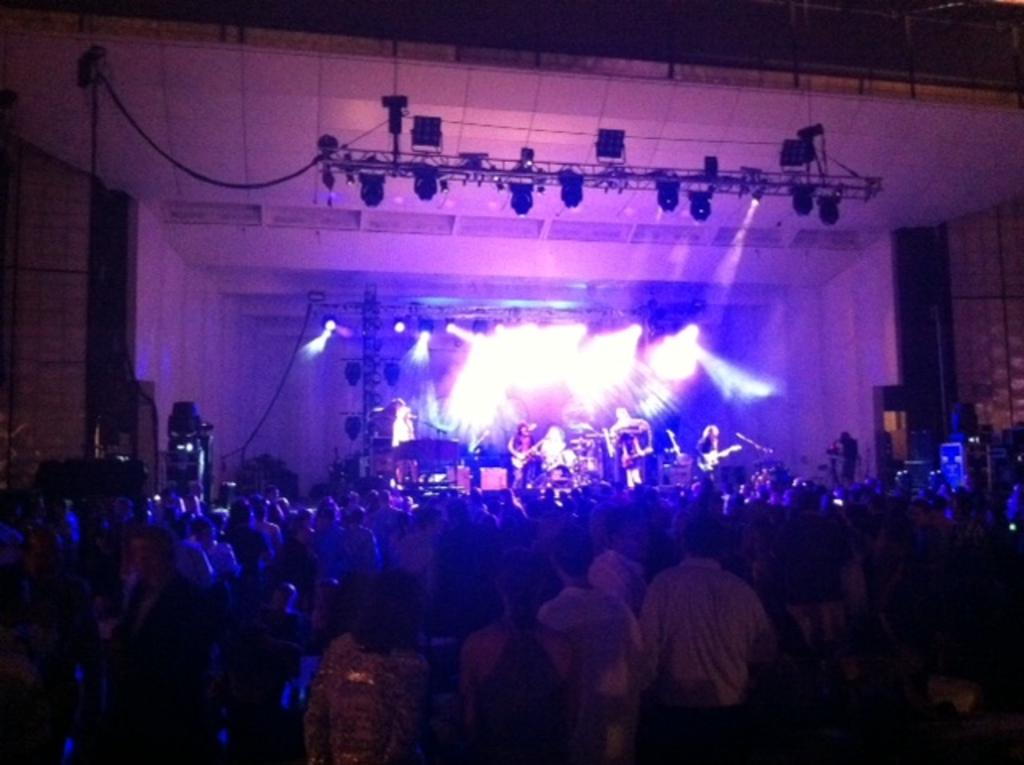What are the people in the front of the image doing? The people in the front of the image are standing. What is happening in the background of the image? There are people playing musical instruments in the background of the image. What else can be seen in the background of the image? There are lights visible in the background of the image. What type of cord is being used to hold up the linen in the image? There is no cord or linen present in the image. How is the popcorn being served in the image? There is no popcorn present in the image. 